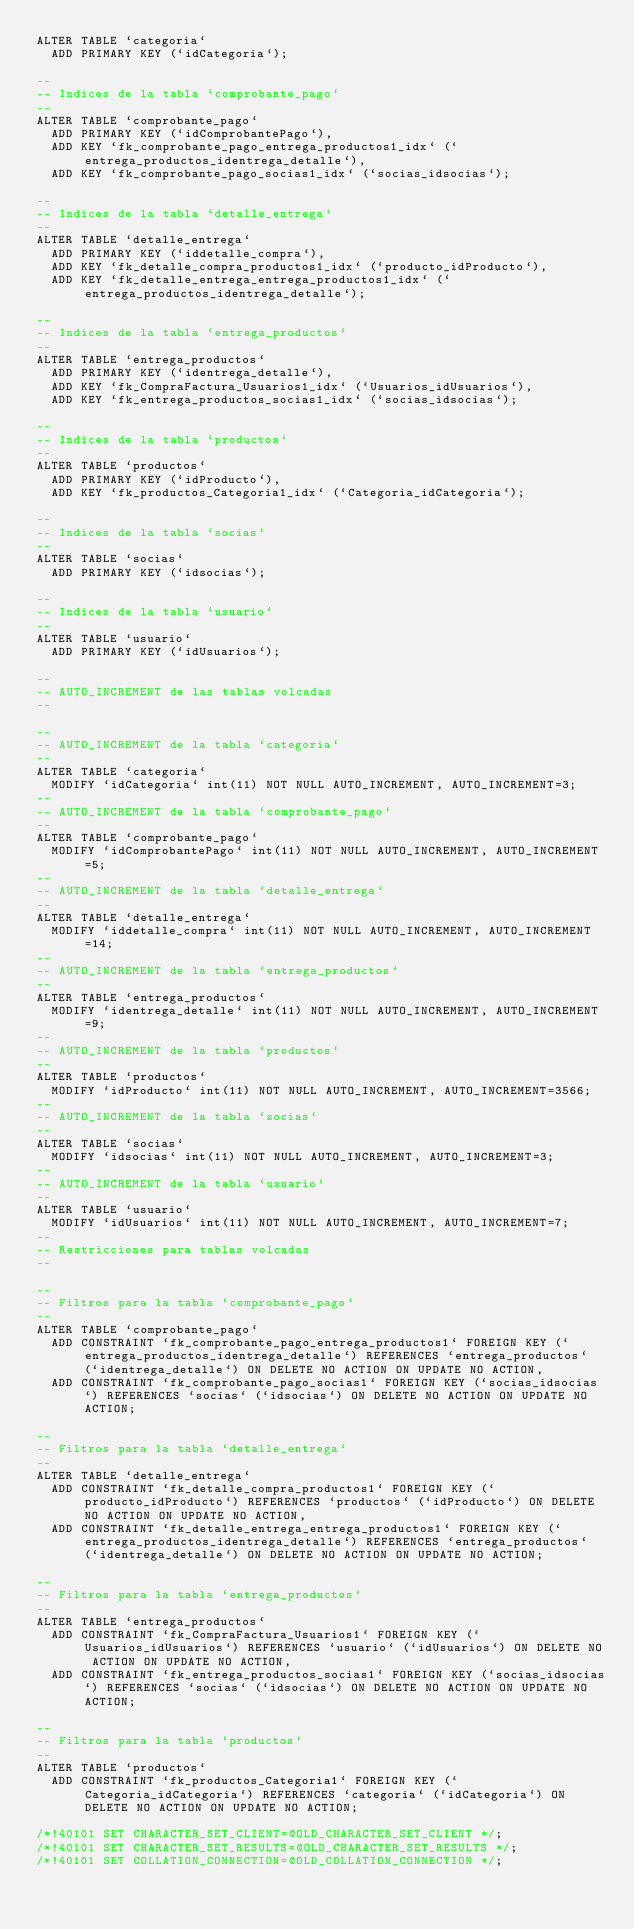Convert code to text. <code><loc_0><loc_0><loc_500><loc_500><_SQL_>ALTER TABLE `categoria`
  ADD PRIMARY KEY (`idCategoria`);

--
-- Indices de la tabla `comprobante_pago`
--
ALTER TABLE `comprobante_pago`
  ADD PRIMARY KEY (`idComprobantePago`),
  ADD KEY `fk_comprobante_pago_entrega_productos1_idx` (`entrega_productos_identrega_detalle`),
  ADD KEY `fk_comprobante_pago_socias1_idx` (`socias_idsocias`);

--
-- Indices de la tabla `detalle_entrega`
--
ALTER TABLE `detalle_entrega`
  ADD PRIMARY KEY (`iddetalle_compra`),
  ADD KEY `fk_detalle_compra_productos1_idx` (`producto_idProducto`),
  ADD KEY `fk_detalle_entrega_entrega_productos1_idx` (`entrega_productos_identrega_detalle`);

--
-- Indices de la tabla `entrega_productos`
--
ALTER TABLE `entrega_productos`
  ADD PRIMARY KEY (`identrega_detalle`),
  ADD KEY `fk_CompraFactura_Usuarios1_idx` (`Usuarios_idUsuarios`),
  ADD KEY `fk_entrega_productos_socias1_idx` (`socias_idsocias`);

--
-- Indices de la tabla `productos`
--
ALTER TABLE `productos`
  ADD PRIMARY KEY (`idProducto`),
  ADD KEY `fk_productos_Categoria1_idx` (`Categoria_idCategoria`);

--
-- Indices de la tabla `socias`
--
ALTER TABLE `socias`
  ADD PRIMARY KEY (`idsocias`);

--
-- Indices de la tabla `usuario`
--
ALTER TABLE `usuario`
  ADD PRIMARY KEY (`idUsuarios`);

--
-- AUTO_INCREMENT de las tablas volcadas
--

--
-- AUTO_INCREMENT de la tabla `categoria`
--
ALTER TABLE `categoria`
  MODIFY `idCategoria` int(11) NOT NULL AUTO_INCREMENT, AUTO_INCREMENT=3;
--
-- AUTO_INCREMENT de la tabla `comprobante_pago`
--
ALTER TABLE `comprobante_pago`
  MODIFY `idComprobantePago` int(11) NOT NULL AUTO_INCREMENT, AUTO_INCREMENT=5;
--
-- AUTO_INCREMENT de la tabla `detalle_entrega`
--
ALTER TABLE `detalle_entrega`
  MODIFY `iddetalle_compra` int(11) NOT NULL AUTO_INCREMENT, AUTO_INCREMENT=14;
--
-- AUTO_INCREMENT de la tabla `entrega_productos`
--
ALTER TABLE `entrega_productos`
  MODIFY `identrega_detalle` int(11) NOT NULL AUTO_INCREMENT, AUTO_INCREMENT=9;
--
-- AUTO_INCREMENT de la tabla `productos`
--
ALTER TABLE `productos`
  MODIFY `idProducto` int(11) NOT NULL AUTO_INCREMENT, AUTO_INCREMENT=3566;
--
-- AUTO_INCREMENT de la tabla `socias`
--
ALTER TABLE `socias`
  MODIFY `idsocias` int(11) NOT NULL AUTO_INCREMENT, AUTO_INCREMENT=3;
--
-- AUTO_INCREMENT de la tabla `usuario`
--
ALTER TABLE `usuario`
  MODIFY `idUsuarios` int(11) NOT NULL AUTO_INCREMENT, AUTO_INCREMENT=7;
--
-- Restricciones para tablas volcadas
--

--
-- Filtros para la tabla `comprobante_pago`
--
ALTER TABLE `comprobante_pago`
  ADD CONSTRAINT `fk_comprobante_pago_entrega_productos1` FOREIGN KEY (`entrega_productos_identrega_detalle`) REFERENCES `entrega_productos` (`identrega_detalle`) ON DELETE NO ACTION ON UPDATE NO ACTION,
  ADD CONSTRAINT `fk_comprobante_pago_socias1` FOREIGN KEY (`socias_idsocias`) REFERENCES `socias` (`idsocias`) ON DELETE NO ACTION ON UPDATE NO ACTION;

--
-- Filtros para la tabla `detalle_entrega`
--
ALTER TABLE `detalle_entrega`
  ADD CONSTRAINT `fk_detalle_compra_productos1` FOREIGN KEY (`producto_idProducto`) REFERENCES `productos` (`idProducto`) ON DELETE NO ACTION ON UPDATE NO ACTION,
  ADD CONSTRAINT `fk_detalle_entrega_entrega_productos1` FOREIGN KEY (`entrega_productos_identrega_detalle`) REFERENCES `entrega_productos` (`identrega_detalle`) ON DELETE NO ACTION ON UPDATE NO ACTION;

--
-- Filtros para la tabla `entrega_productos`
--
ALTER TABLE `entrega_productos`
  ADD CONSTRAINT `fk_CompraFactura_Usuarios1` FOREIGN KEY (`Usuarios_idUsuarios`) REFERENCES `usuario` (`idUsuarios`) ON DELETE NO ACTION ON UPDATE NO ACTION,
  ADD CONSTRAINT `fk_entrega_productos_socias1` FOREIGN KEY (`socias_idsocias`) REFERENCES `socias` (`idsocias`) ON DELETE NO ACTION ON UPDATE NO ACTION;

--
-- Filtros para la tabla `productos`
--
ALTER TABLE `productos`
  ADD CONSTRAINT `fk_productos_Categoria1` FOREIGN KEY (`Categoria_idCategoria`) REFERENCES `categoria` (`idCategoria`) ON DELETE NO ACTION ON UPDATE NO ACTION;

/*!40101 SET CHARACTER_SET_CLIENT=@OLD_CHARACTER_SET_CLIENT */;
/*!40101 SET CHARACTER_SET_RESULTS=@OLD_CHARACTER_SET_RESULTS */;
/*!40101 SET COLLATION_CONNECTION=@OLD_COLLATION_CONNECTION */;
</code> 